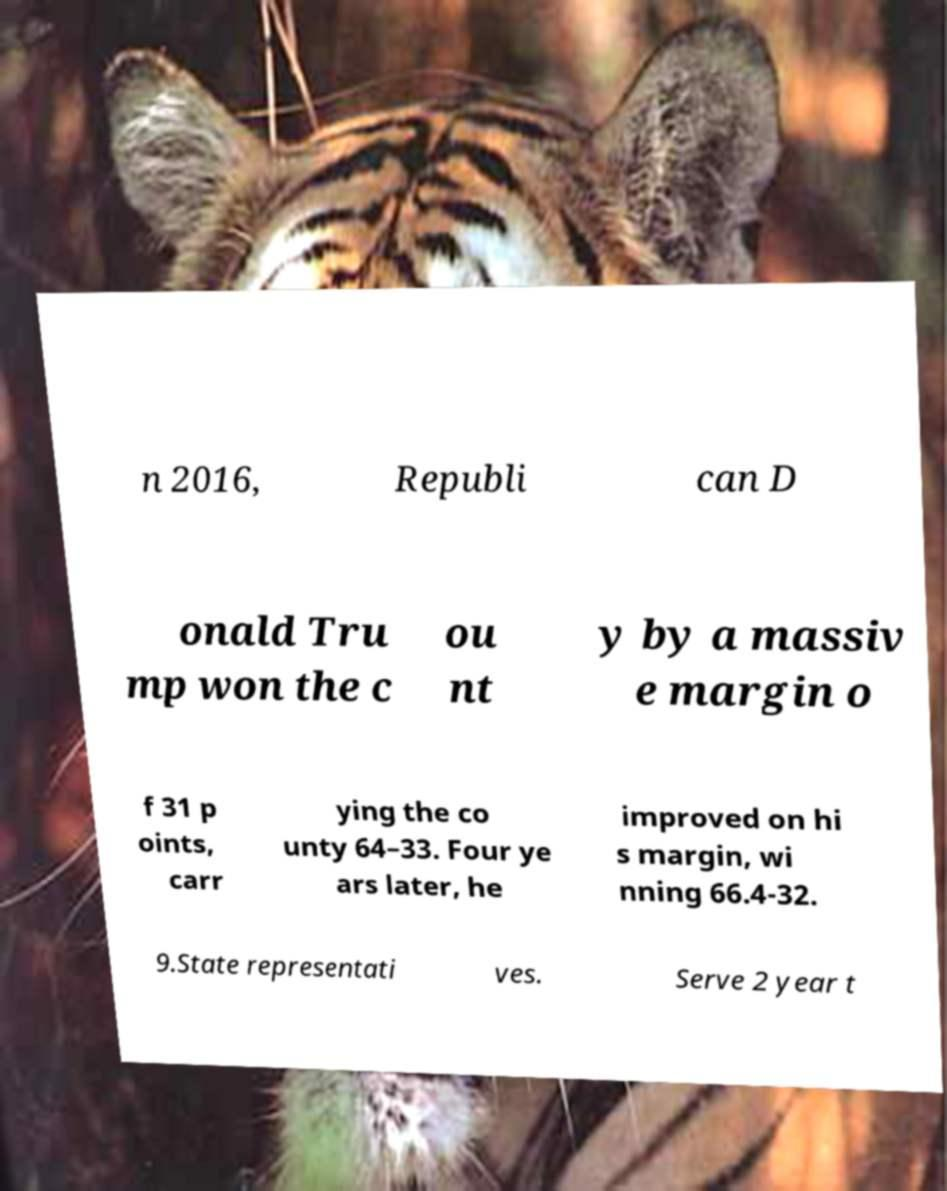I need the written content from this picture converted into text. Can you do that? n 2016, Republi can D onald Tru mp won the c ou nt y by a massiv e margin o f 31 p oints, carr ying the co unty 64–33. Four ye ars later, he improved on hi s margin, wi nning 66.4-32. 9.State representati ves. Serve 2 year t 